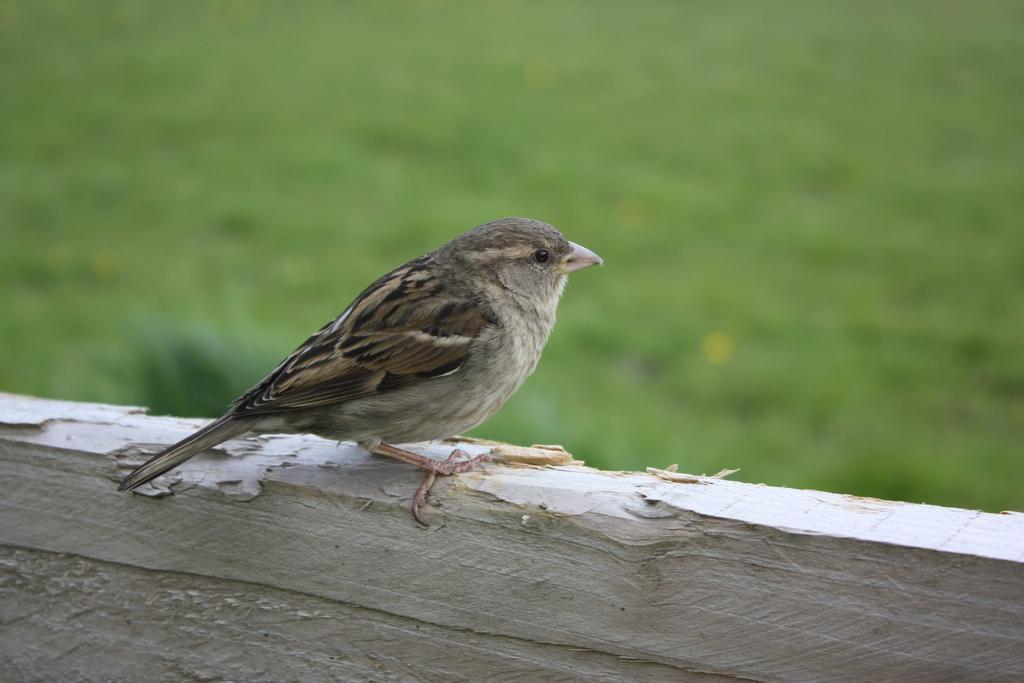How would you summarize this image in a sentence or two? In this picture, we see a sparrow is on the wooden wall. In the background, it is green in color. This picture is blurred in the background. 